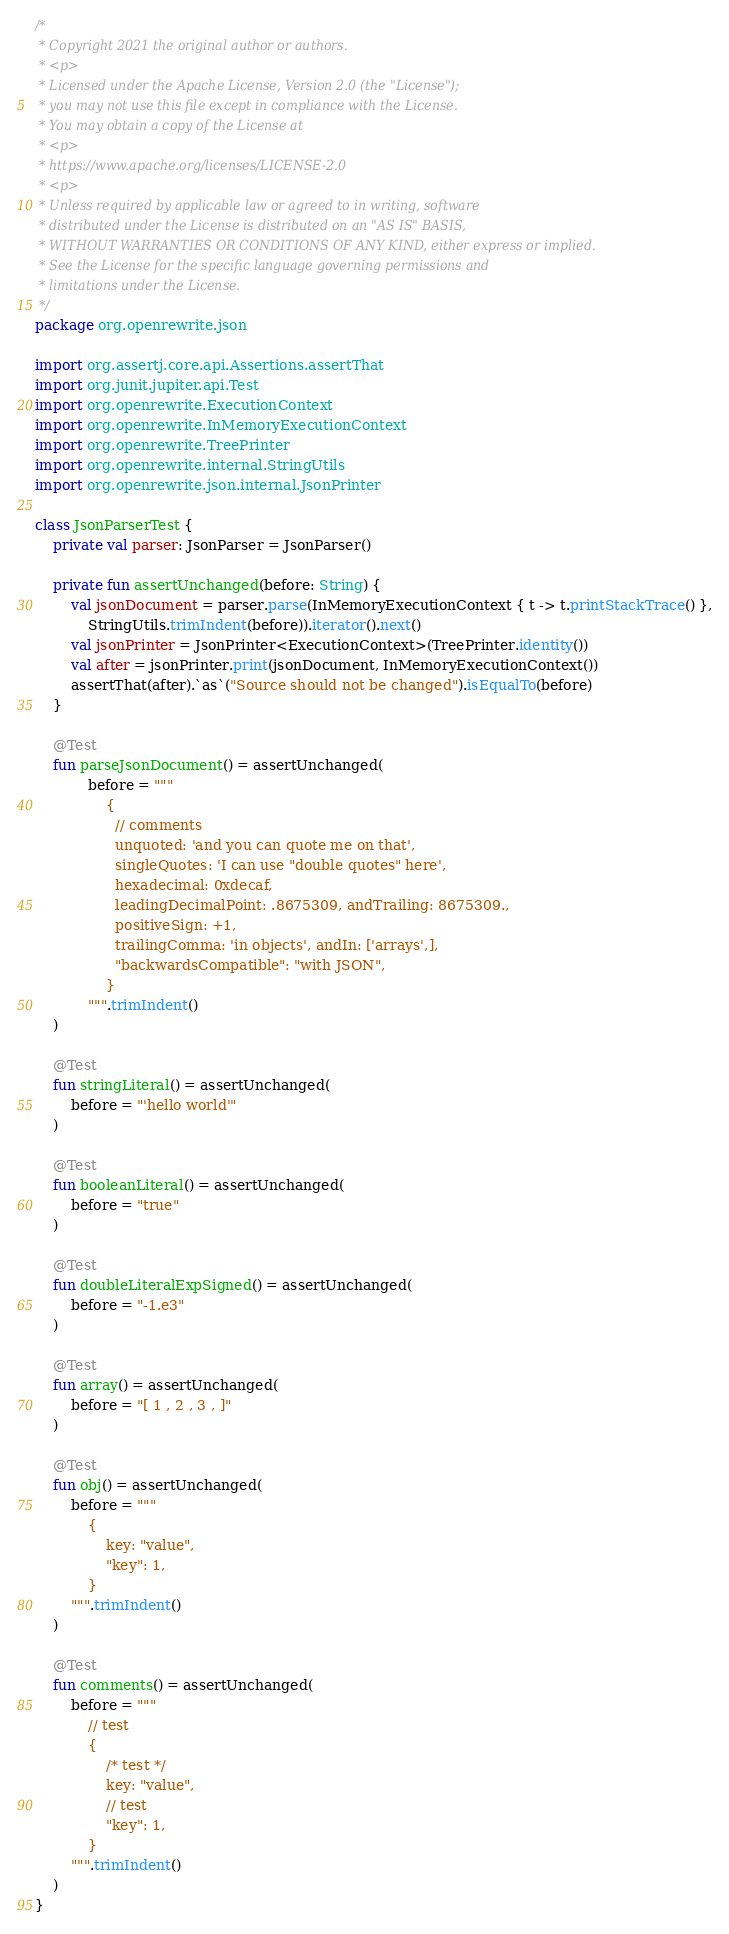<code> <loc_0><loc_0><loc_500><loc_500><_Kotlin_>/*
 * Copyright 2021 the original author or authors.
 * <p>
 * Licensed under the Apache License, Version 2.0 (the "License");
 * you may not use this file except in compliance with the License.
 * You may obtain a copy of the License at
 * <p>
 * https://www.apache.org/licenses/LICENSE-2.0
 * <p>
 * Unless required by applicable law or agreed to in writing, software
 * distributed under the License is distributed on an "AS IS" BASIS,
 * WITHOUT WARRANTIES OR CONDITIONS OF ANY KIND, either express or implied.
 * See the License for the specific language governing permissions and
 * limitations under the License.
 */
package org.openrewrite.json

import org.assertj.core.api.Assertions.assertThat
import org.junit.jupiter.api.Test
import org.openrewrite.ExecutionContext
import org.openrewrite.InMemoryExecutionContext
import org.openrewrite.TreePrinter
import org.openrewrite.internal.StringUtils
import org.openrewrite.json.internal.JsonPrinter

class JsonParserTest {
    private val parser: JsonParser = JsonParser()

    private fun assertUnchanged(before: String) {
        val jsonDocument = parser.parse(InMemoryExecutionContext { t -> t.printStackTrace() },
            StringUtils.trimIndent(before)).iterator().next()
        val jsonPrinter = JsonPrinter<ExecutionContext>(TreePrinter.identity())
        val after = jsonPrinter.print(jsonDocument, InMemoryExecutionContext())
        assertThat(after).`as`("Source should not be changed").isEqualTo(before)
    }

    @Test
    fun parseJsonDocument() = assertUnchanged(
            before = """
                {
                  // comments
                  unquoted: 'and you can quote me on that',
                  singleQuotes: 'I can use "double quotes" here',
                  hexadecimal: 0xdecaf,
                  leadingDecimalPoint: .8675309, andTrailing: 8675309.,
                  positiveSign: +1,
                  trailingComma: 'in objects', andIn: ['arrays',],
                  "backwardsCompatible": "with JSON",
                }
            """.trimIndent()
    )

    @Test
    fun stringLiteral() = assertUnchanged(
        before = "'hello world'"
    )

    @Test
    fun booleanLiteral() = assertUnchanged(
        before = "true"
    )

    @Test
    fun doubleLiteralExpSigned() = assertUnchanged(
        before = "-1.e3"
    )

    @Test
    fun array() = assertUnchanged(
        before = "[ 1 , 2 , 3 , ]"
    )

    @Test
    fun obj() = assertUnchanged(
        before = """
            {
                key: "value",
                "key": 1,
            }
        """.trimIndent()
    )

    @Test
    fun comments() = assertUnchanged(
        before = """
            // test
            {
                /* test */
                key: "value",
                // test
                "key": 1,
            }
        """.trimIndent()
    )
}
</code> 